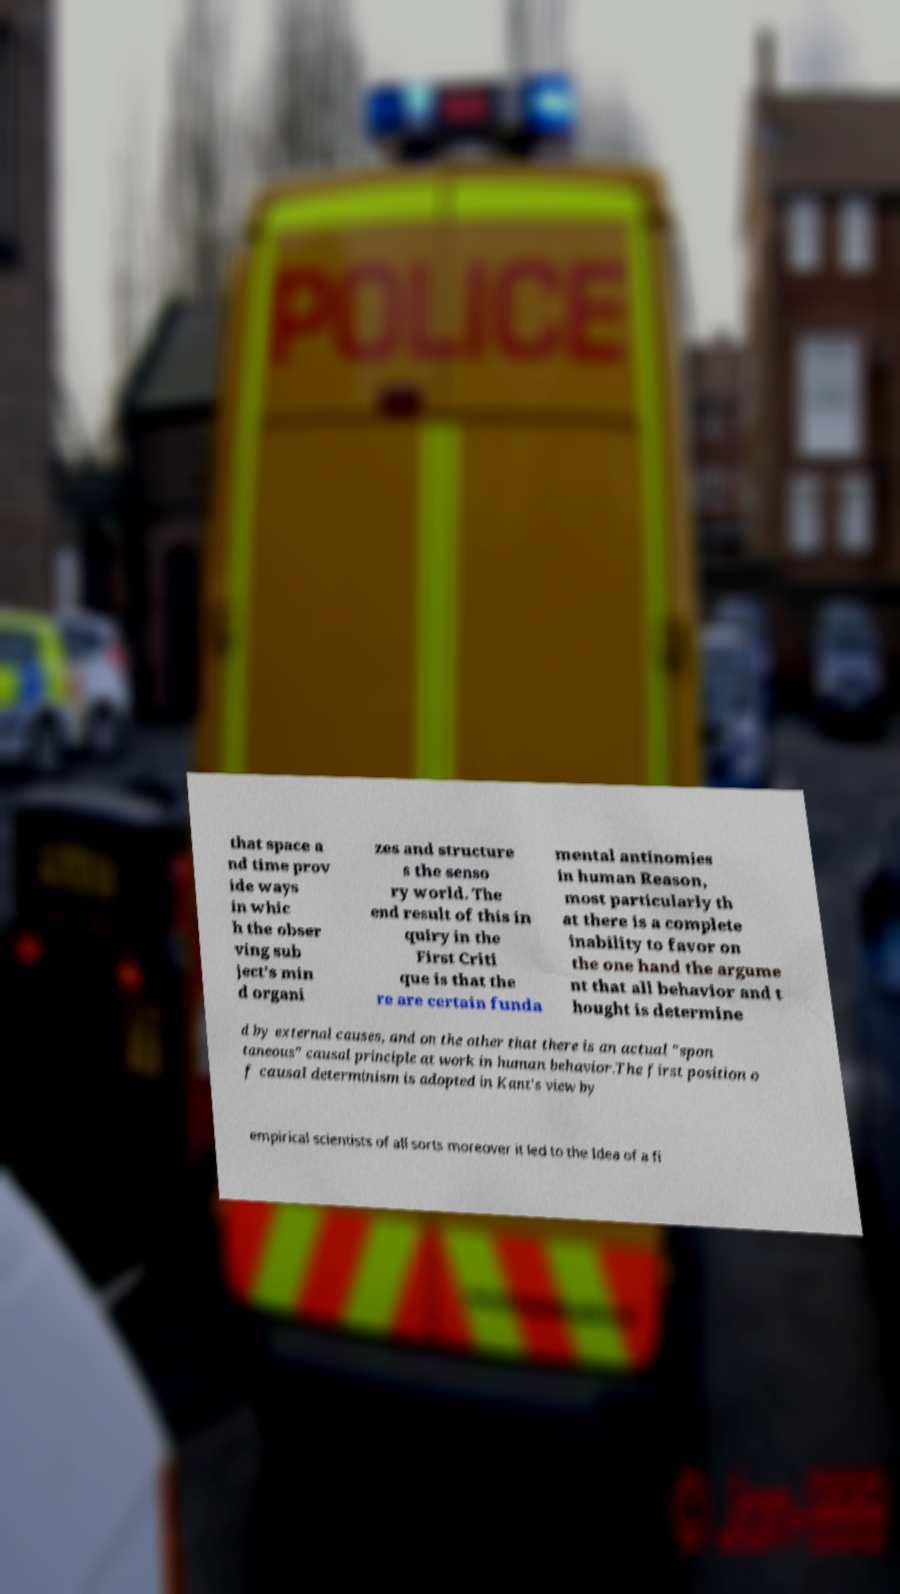There's text embedded in this image that I need extracted. Can you transcribe it verbatim? that space a nd time prov ide ways in whic h the obser ving sub ject's min d organi zes and structure s the senso ry world. The end result of this in quiry in the First Criti que is that the re are certain funda mental antinomies in human Reason, most particularly th at there is a complete inability to favor on the one hand the argume nt that all behavior and t hought is determine d by external causes, and on the other that there is an actual "spon taneous" causal principle at work in human behavior.The first position o f causal determinism is adopted in Kant's view by empirical scientists of all sorts moreover it led to the Idea of a fi 